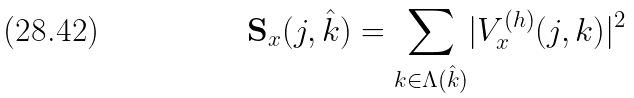<formula> <loc_0><loc_0><loc_500><loc_500>\mathbf S _ { x } ( j , \hat { k } ) = \underset { k \in \Lambda ( \hat { k } ) } { \sum } | V ^ { ( h ) } _ { x } ( j , k ) | ^ { 2 }</formula> 